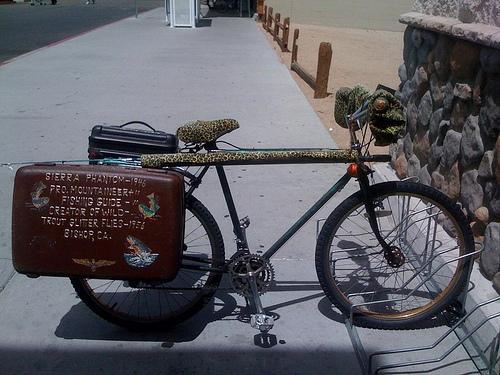Is this at the beach?
Keep it brief. Yes. What type of bike is this?
Answer briefly. Passenger. What is on the sides of the bike?
Give a very brief answer. Suitcases. Is there enough wheels to ride this?
Keep it brief. Yes. Is this bike worn out?
Quick response, please. Yes. Is this around the World War II time?
Short answer required. No. What does the box on the bike say?
Quick response, please. Sierra phantom. 